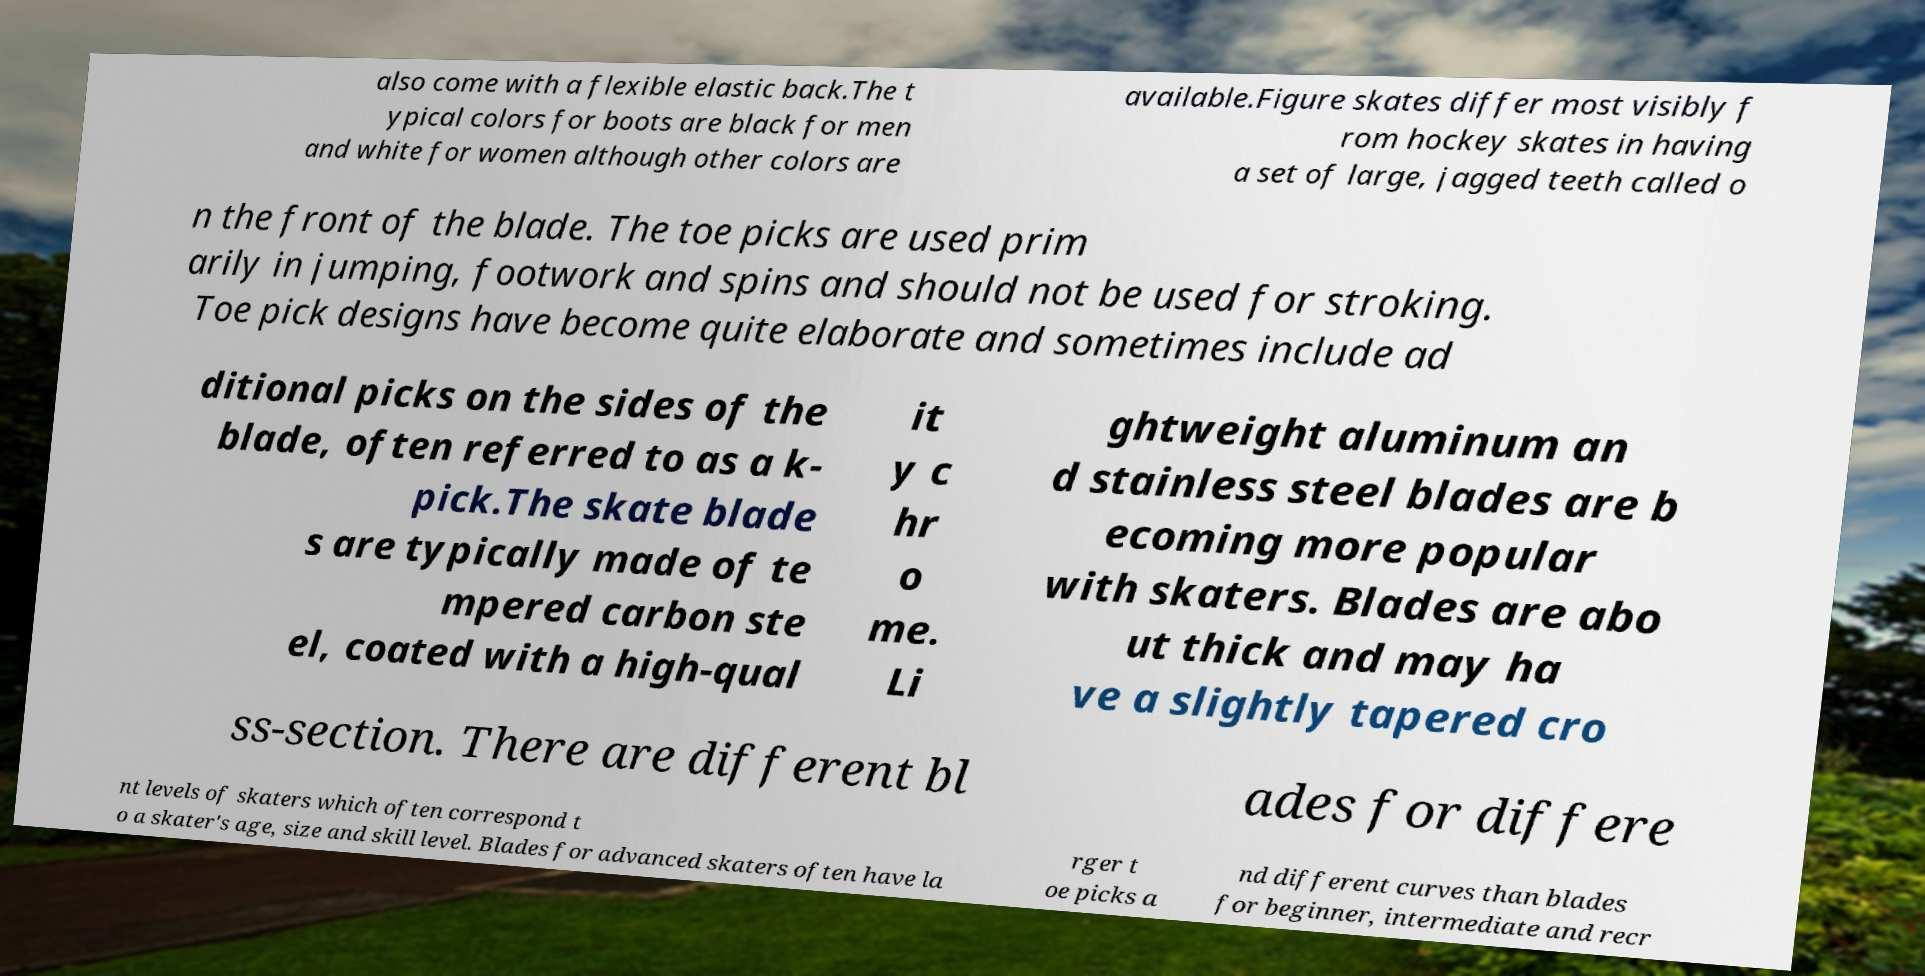What messages or text are displayed in this image? I need them in a readable, typed format. also come with a flexible elastic back.The t ypical colors for boots are black for men and white for women although other colors are available.Figure skates differ most visibly f rom hockey skates in having a set of large, jagged teeth called o n the front of the blade. The toe picks are used prim arily in jumping, footwork and spins and should not be used for stroking. Toe pick designs have become quite elaborate and sometimes include ad ditional picks on the sides of the blade, often referred to as a k- pick.The skate blade s are typically made of te mpered carbon ste el, coated with a high-qual it y c hr o me. Li ghtweight aluminum an d stainless steel blades are b ecoming more popular with skaters. Blades are abo ut thick and may ha ve a slightly tapered cro ss-section. There are different bl ades for differe nt levels of skaters which often correspond t o a skater's age, size and skill level. Blades for advanced skaters often have la rger t oe picks a nd different curves than blades for beginner, intermediate and recr 